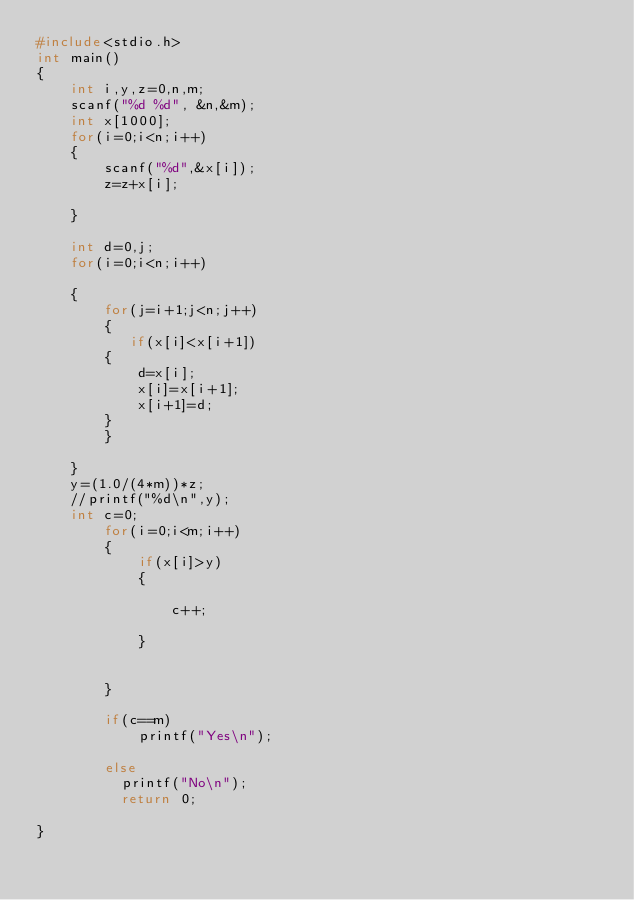<code> <loc_0><loc_0><loc_500><loc_500><_C_>#include<stdio.h>
int main()
{
    int i,y,z=0,n,m;
    scanf("%d %d", &n,&m);
    int x[1000];
    for(i=0;i<n;i++)
    {
        scanf("%d",&x[i]);
        z=z+x[i];

    }

    int d=0,j;
    for(i=0;i<n;i++)

    {
        for(j=i+1;j<n;j++)
        {
           if(x[i]<x[i+1])
        {
            d=x[i];
            x[i]=x[i+1];
            x[i+1]=d;
        }
        }

    }
    y=(1.0/(4*m))*z;
    //printf("%d\n",y);
    int c=0;
        for(i=0;i<m;i++)
        {
            if(x[i]>y)
            {

                c++;

            }


        }

        if(c==m)
            printf("Yes\n");

        else
          printf("No\n");
          return 0;

}
</code> 